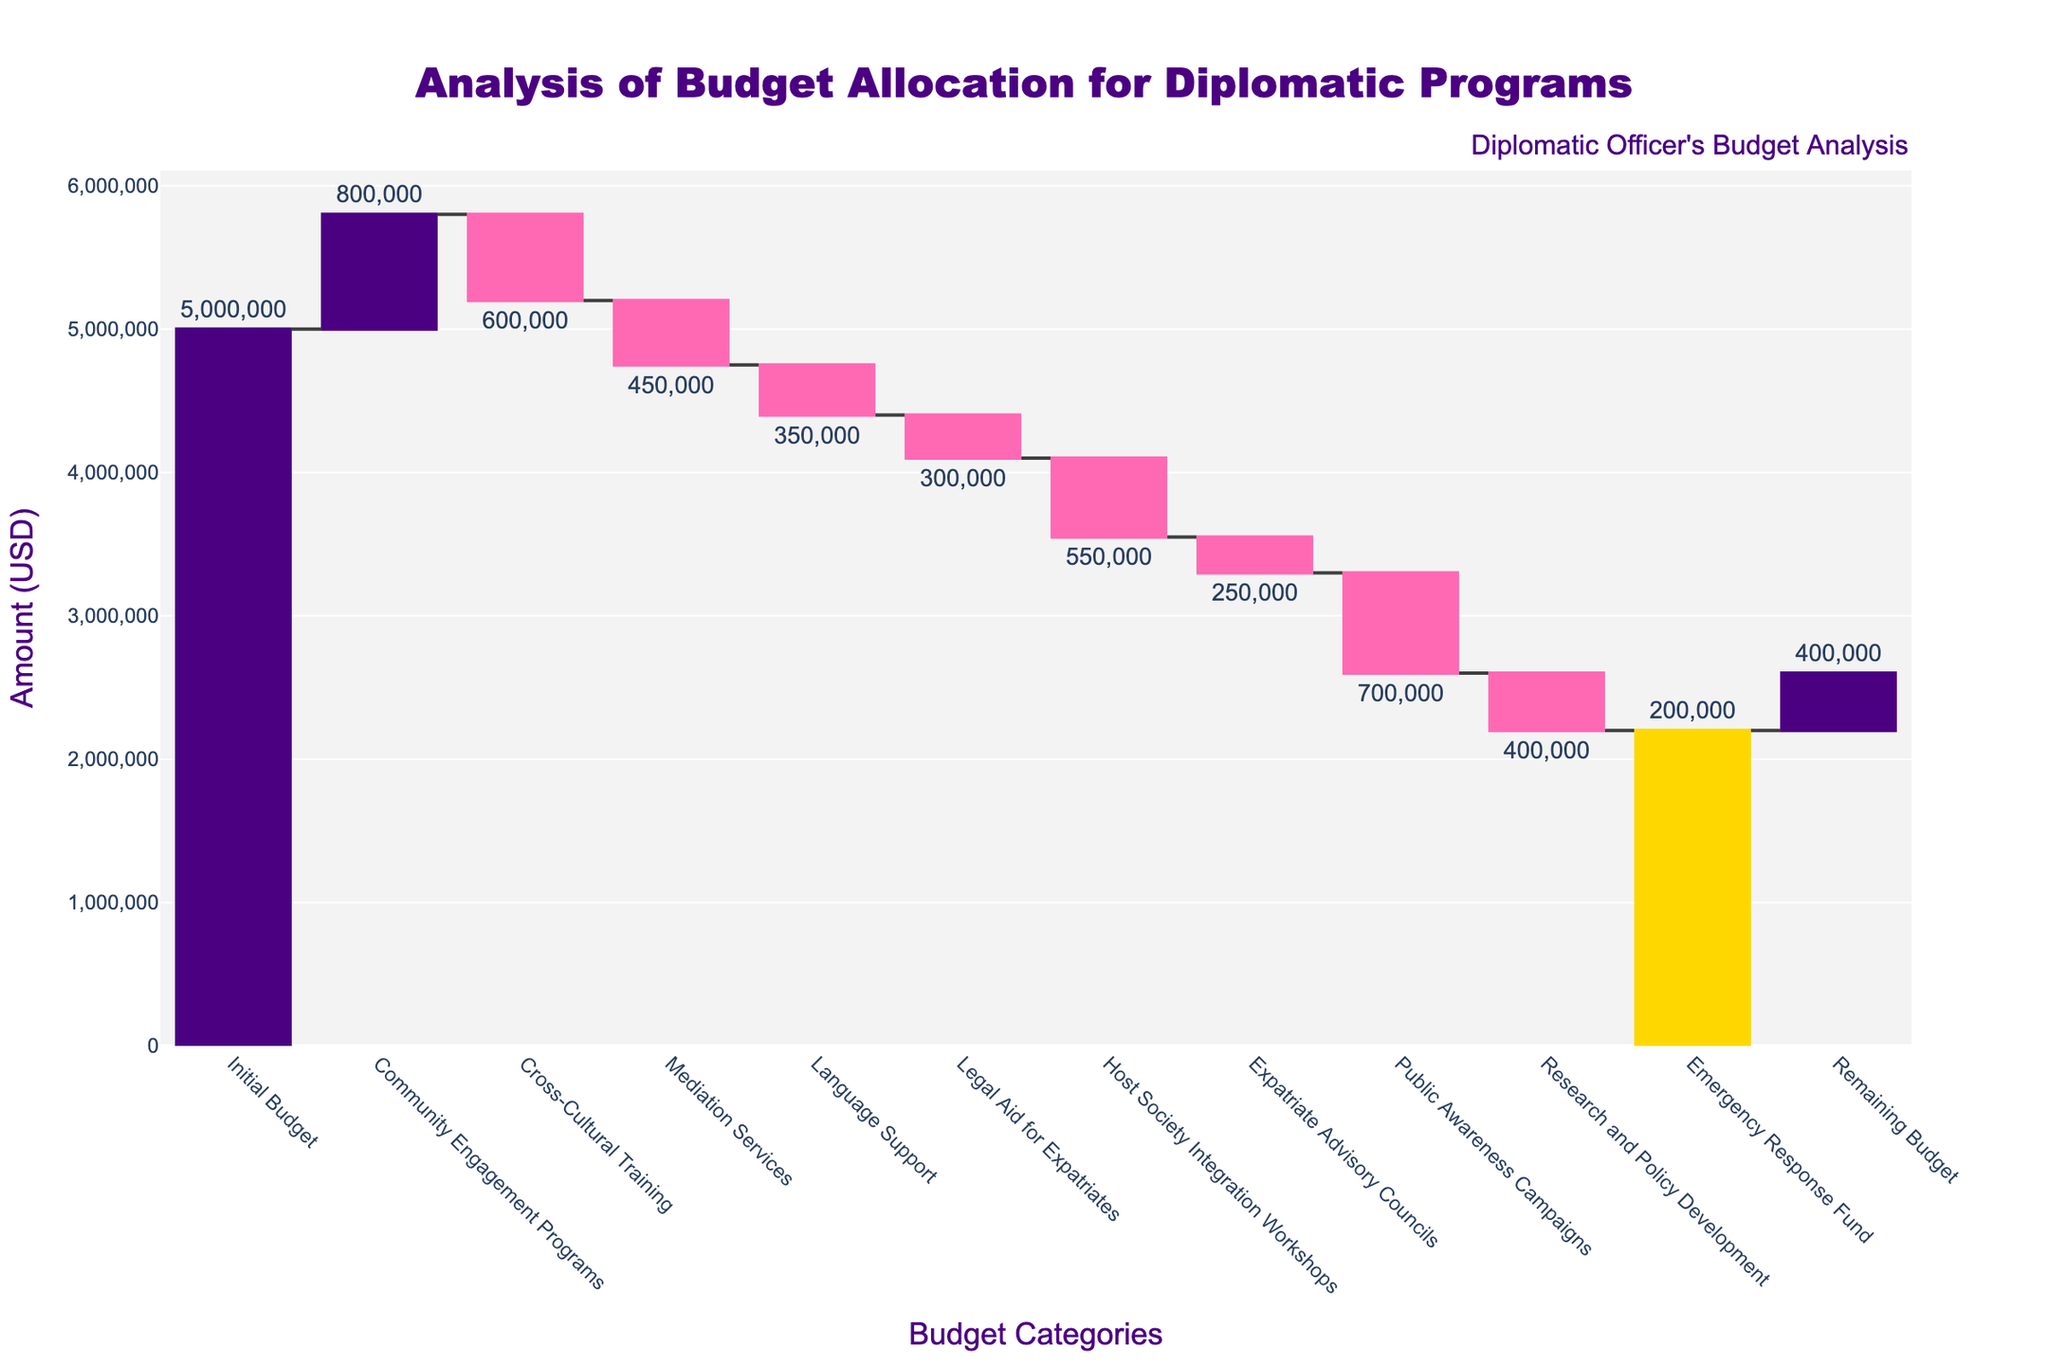1. What is the initial budget for the diplomatic programs? The initial budget is indicated as the first bar in the waterfall chart labeled "Initial Budget." According to the chart, it's 5,000,000.
Answer: 5,000,000 2. How much budget was allocated for Community Engagement Programs? The second bar in the waterfall chart represents the budget for Community Engagement Programs, which is 800,000.
Answer: 800,000 3. Which category had the highest budget reduction? To find the category with the highest budget reduction, look for the bar with the largest negative value. The "Public Awareness Campaigns" bar has the highest reduction of 700,000.
Answer: Public Awareness Campaigns 4. What is the total reduction in the budget from Cross-Cultural Training, Mediation Services, and Language Support combined? The reductions are -600,000 for Cross-Cultural Training, -450,000 for Mediation Services, and -350,000 for Language Support. The total is -600,000 + -450,000 + -350,000 = -1,400,000.
Answer: -1,400,000 5. By how much did the initial budget decrease after funding Research and Policy Development? The reduction for Research and Policy Development is -400,000. After deducting this from the initial budget, the new budget would be 5,000,000 - 400,000 = 4,600,000.
Answer: 4,600,000 6. What is the remaining budget at the end of the allocations? The remaining budget is labeled as "Remaining Budget" at the end of the chart and is indicated as 400,000.
Answer: 400,000 7. How many categories resulted in an increase in the budget? To answer this, count the bars that represent an increase (usually indicated by one color for increases). Only "Community Engagement Programs" shows an increase, so the count is 1.
Answer: 1 8. Which budget category was allocated the least amount of funds? The "Expatriate Advisory Councils" category, with a reduction of -250,000, is the smallest budget allocation.
Answer: Expatriate Advisory Councils 9. What is the cumulative reduction in the budget for categories related to legal and emergency support? Legal Aid for Expatriates has a reduction of -300,000, and Emergency Response Fund has a reduction of -200,000. The cumulative reduction is -300,000 + -200,000 = -500,000.
Answer: -500,000 10. Which categories had a budget allocation between 400,000 to 600,000? The bars for Cross-Cultural Training (-600,000) and Research and Policy Development (-400,000) fall within the range when considering absolute values.
Answer: Cross-Cultural Training, Research and Policy Development 